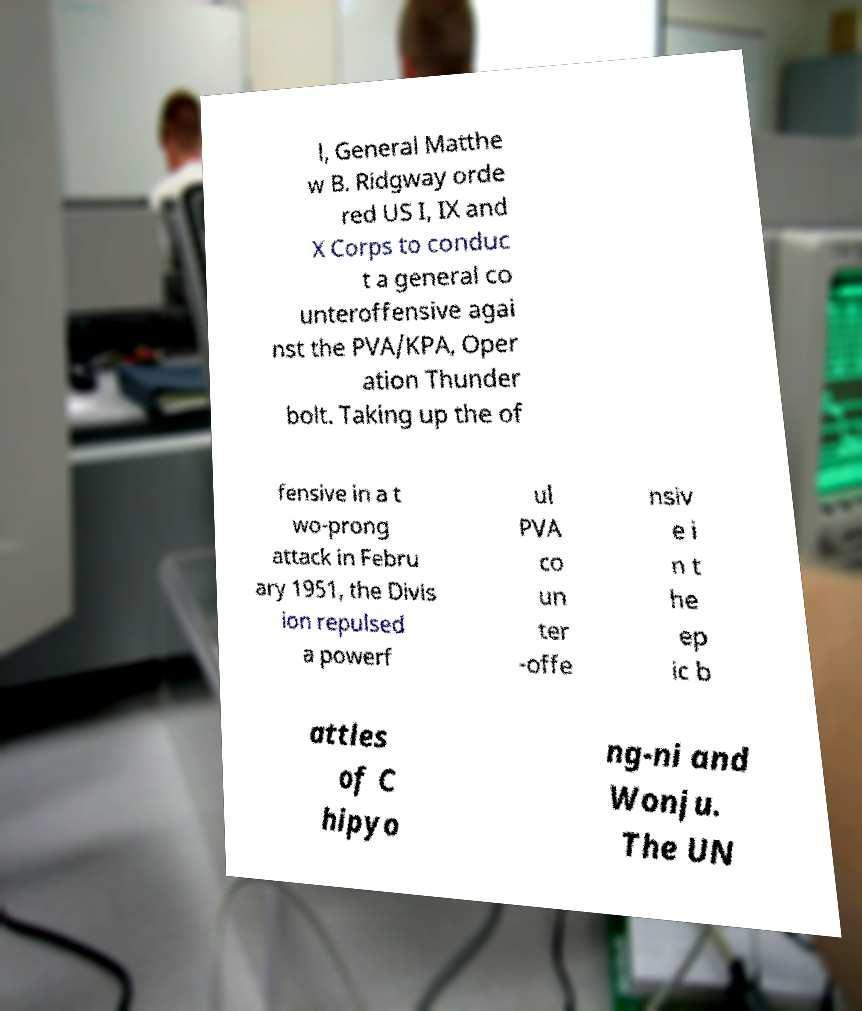Can you read and provide the text displayed in the image?This photo seems to have some interesting text. Can you extract and type it out for me? l, General Matthe w B. Ridgway orde red US I, IX and X Corps to conduc t a general co unteroffensive agai nst the PVA/KPA, Oper ation Thunder bolt. Taking up the of fensive in a t wo-prong attack in Febru ary 1951, the Divis ion repulsed a powerf ul PVA co un ter -offe nsiv e i n t he ep ic b attles of C hipyo ng-ni and Wonju. The UN 